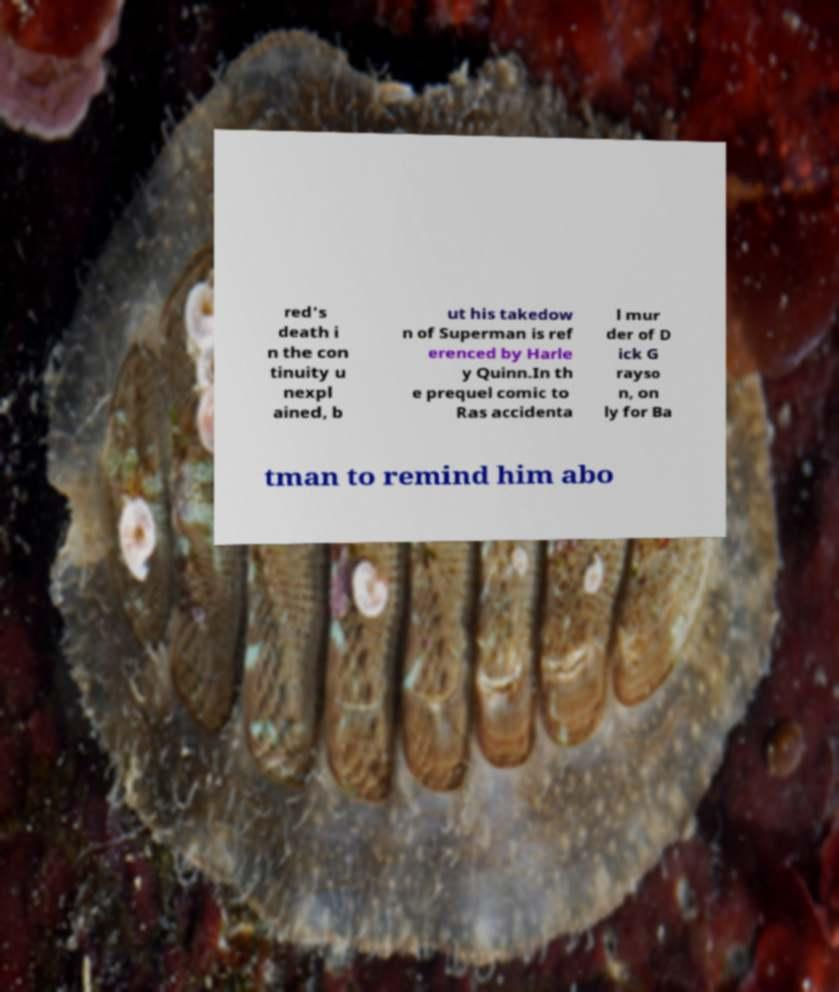Can you read and provide the text displayed in the image?This photo seems to have some interesting text. Can you extract and type it out for me? red's death i n the con tinuity u nexpl ained, b ut his takedow n of Superman is ref erenced by Harle y Quinn.In th e prequel comic to Ras accidenta l mur der of D ick G rayso n, on ly for Ba tman to remind him abo 